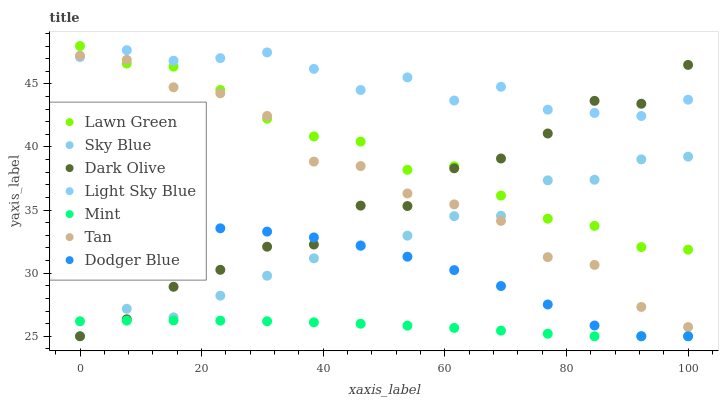Does Mint have the minimum area under the curve?
Answer yes or no. Yes. Does Light Sky Blue have the maximum area under the curve?
Answer yes or no. Yes. Does Dark Olive have the minimum area under the curve?
Answer yes or no. No. Does Dark Olive have the maximum area under the curve?
Answer yes or no. No. Is Mint the smoothest?
Answer yes or no. Yes. Is Dark Olive the roughest?
Answer yes or no. Yes. Is Light Sky Blue the smoothest?
Answer yes or no. No. Is Light Sky Blue the roughest?
Answer yes or no. No. Does Dark Olive have the lowest value?
Answer yes or no. Yes. Does Light Sky Blue have the lowest value?
Answer yes or no. No. Does Lawn Green have the highest value?
Answer yes or no. Yes. Does Dark Olive have the highest value?
Answer yes or no. No. Is Dodger Blue less than Light Sky Blue?
Answer yes or no. Yes. Is Lawn Green greater than Dodger Blue?
Answer yes or no. Yes. Does Lawn Green intersect Tan?
Answer yes or no. Yes. Is Lawn Green less than Tan?
Answer yes or no. No. Is Lawn Green greater than Tan?
Answer yes or no. No. Does Dodger Blue intersect Light Sky Blue?
Answer yes or no. No. 